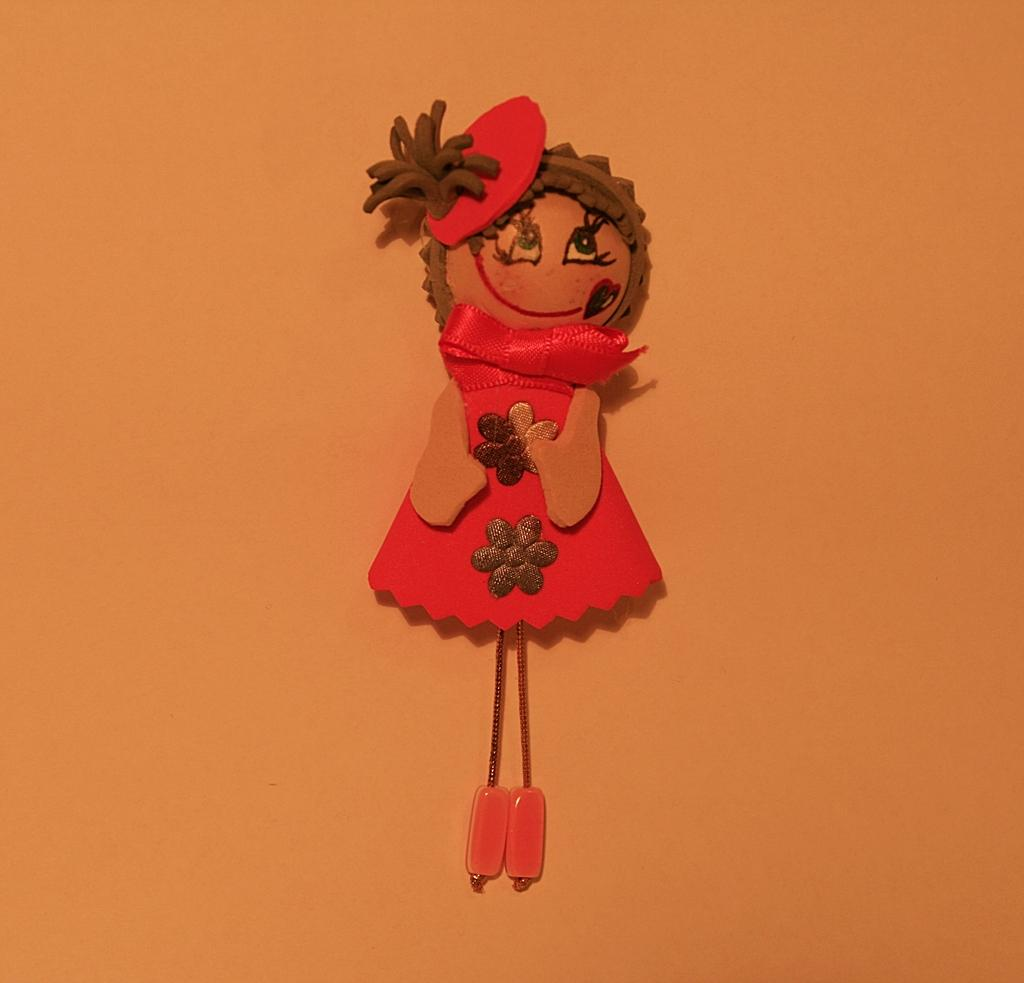What type of toy is depicted in the image? There is a toy sticker in the image. Where is the toy sticker located? The toy sticker is attached to the wall. How is the toy sticker positioned in the image? The toy sticker is in the middle of the image. What type of authority figure is depicted in the image? There is no authority figure present in the image; it features a toy sticker attached to the wall. 